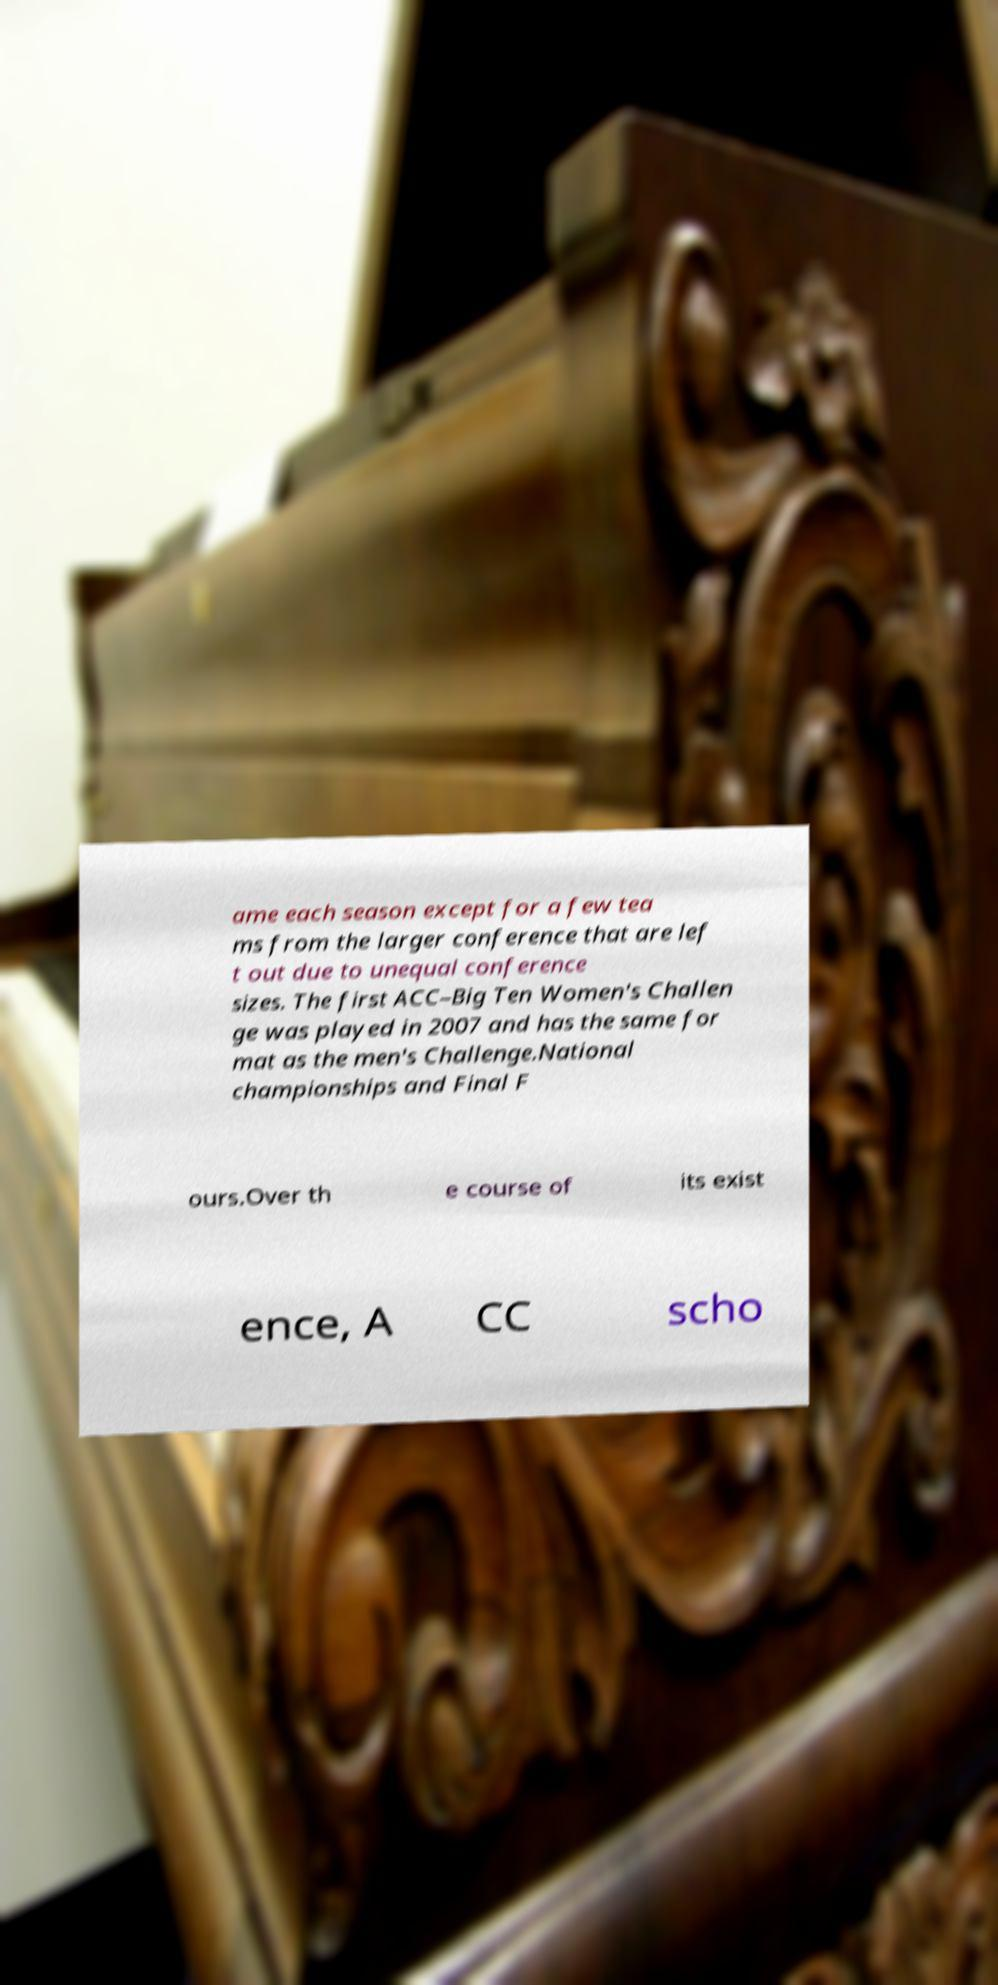For documentation purposes, I need the text within this image transcribed. Could you provide that? ame each season except for a few tea ms from the larger conference that are lef t out due to unequal conference sizes. The first ACC–Big Ten Women's Challen ge was played in 2007 and has the same for mat as the men's Challenge.National championships and Final F ours.Over th e course of its exist ence, A CC scho 